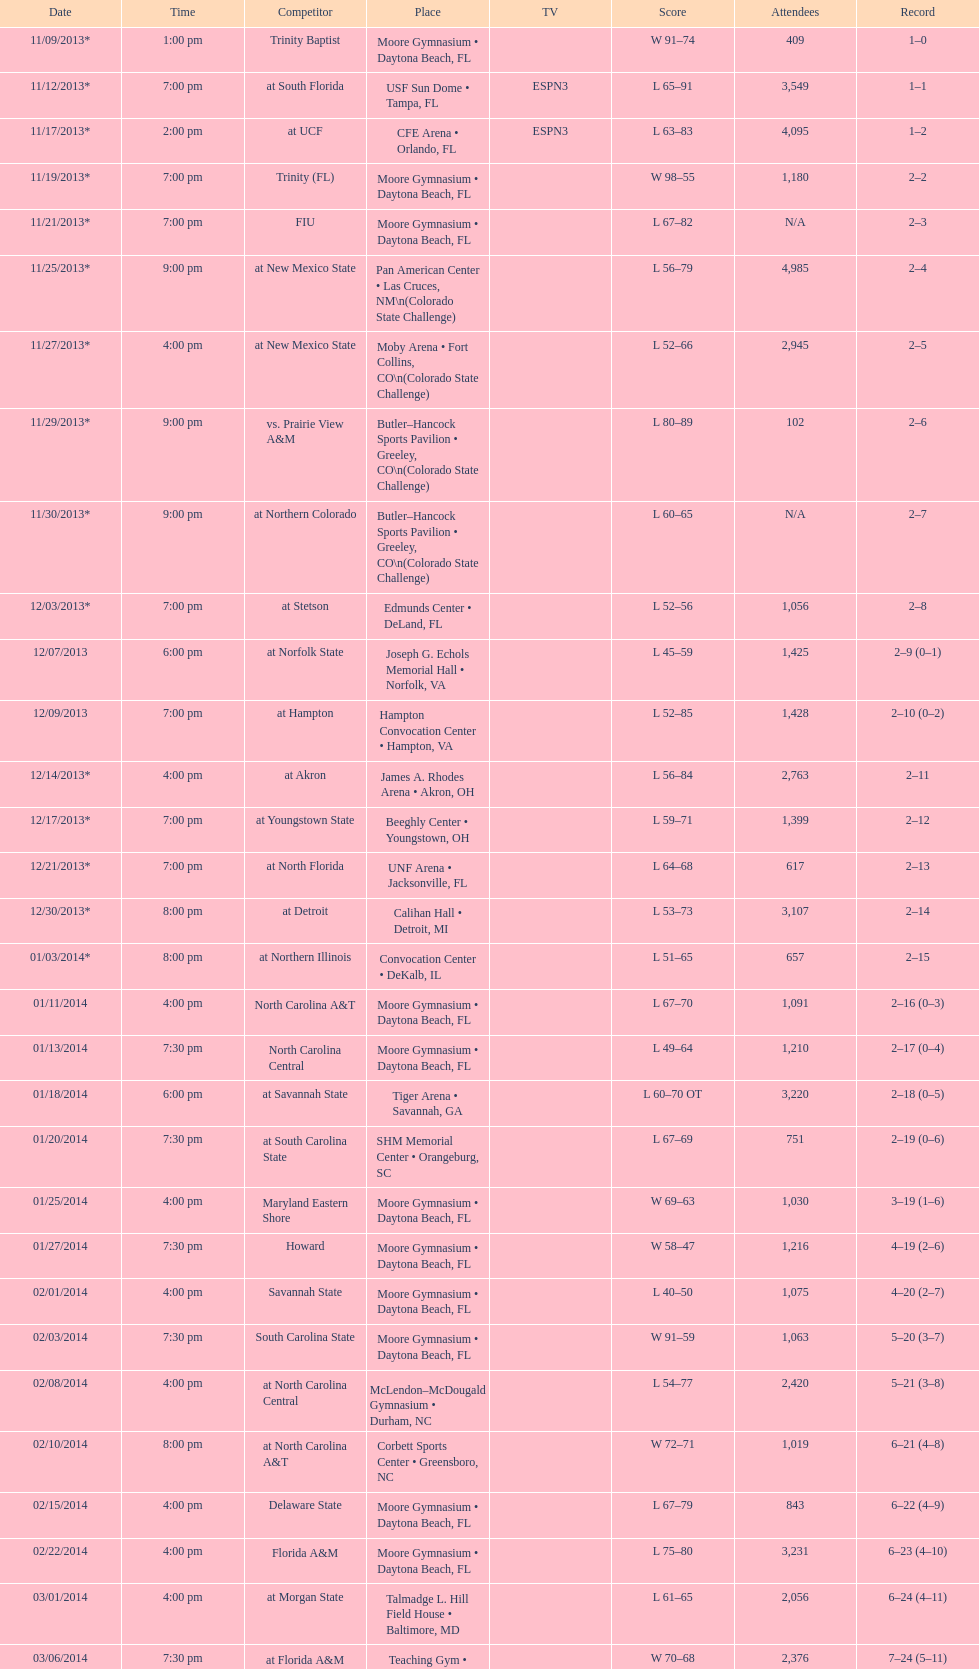How many games did the wildcats play in daytona beach, fl? 11. 